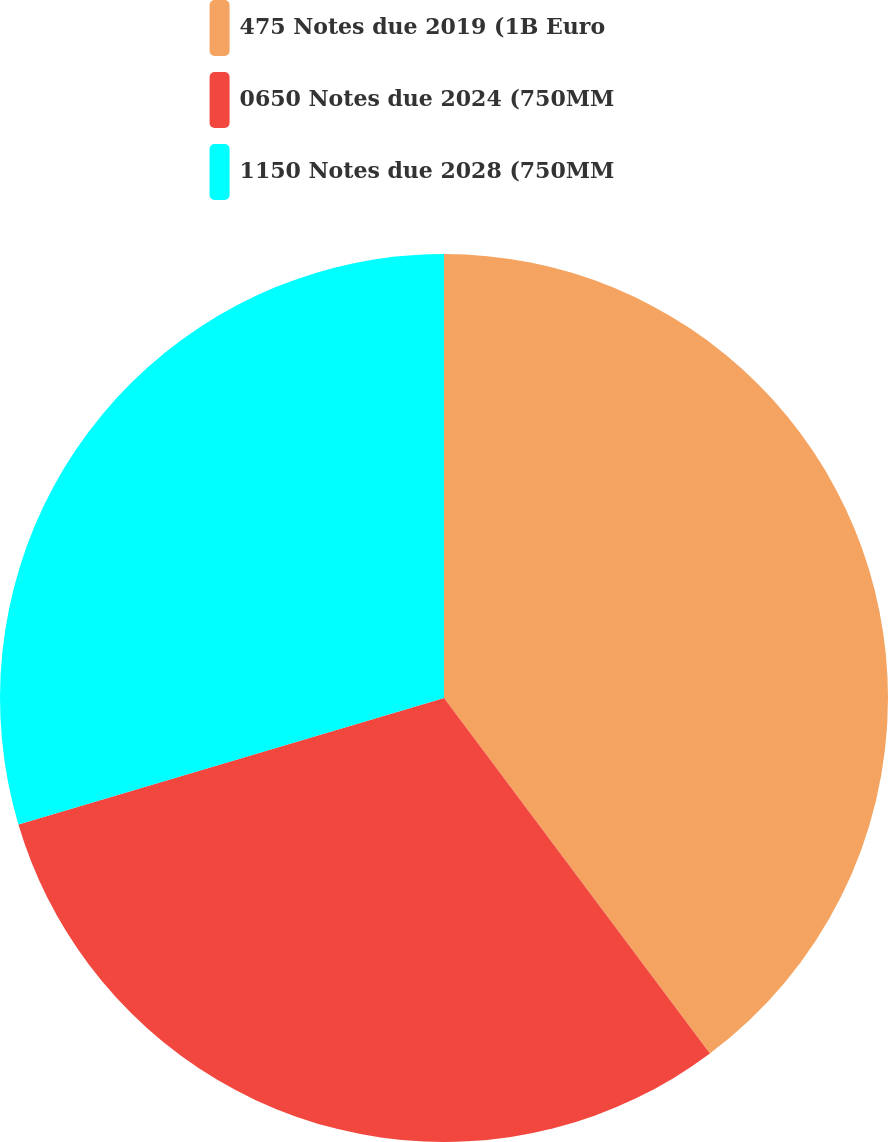Convert chart. <chart><loc_0><loc_0><loc_500><loc_500><pie_chart><fcel>475 Notes due 2019 (1B Euro<fcel>0650 Notes due 2024 (750MM<fcel>1150 Notes due 2028 (750MM<nl><fcel>39.78%<fcel>30.62%<fcel>29.6%<nl></chart> 